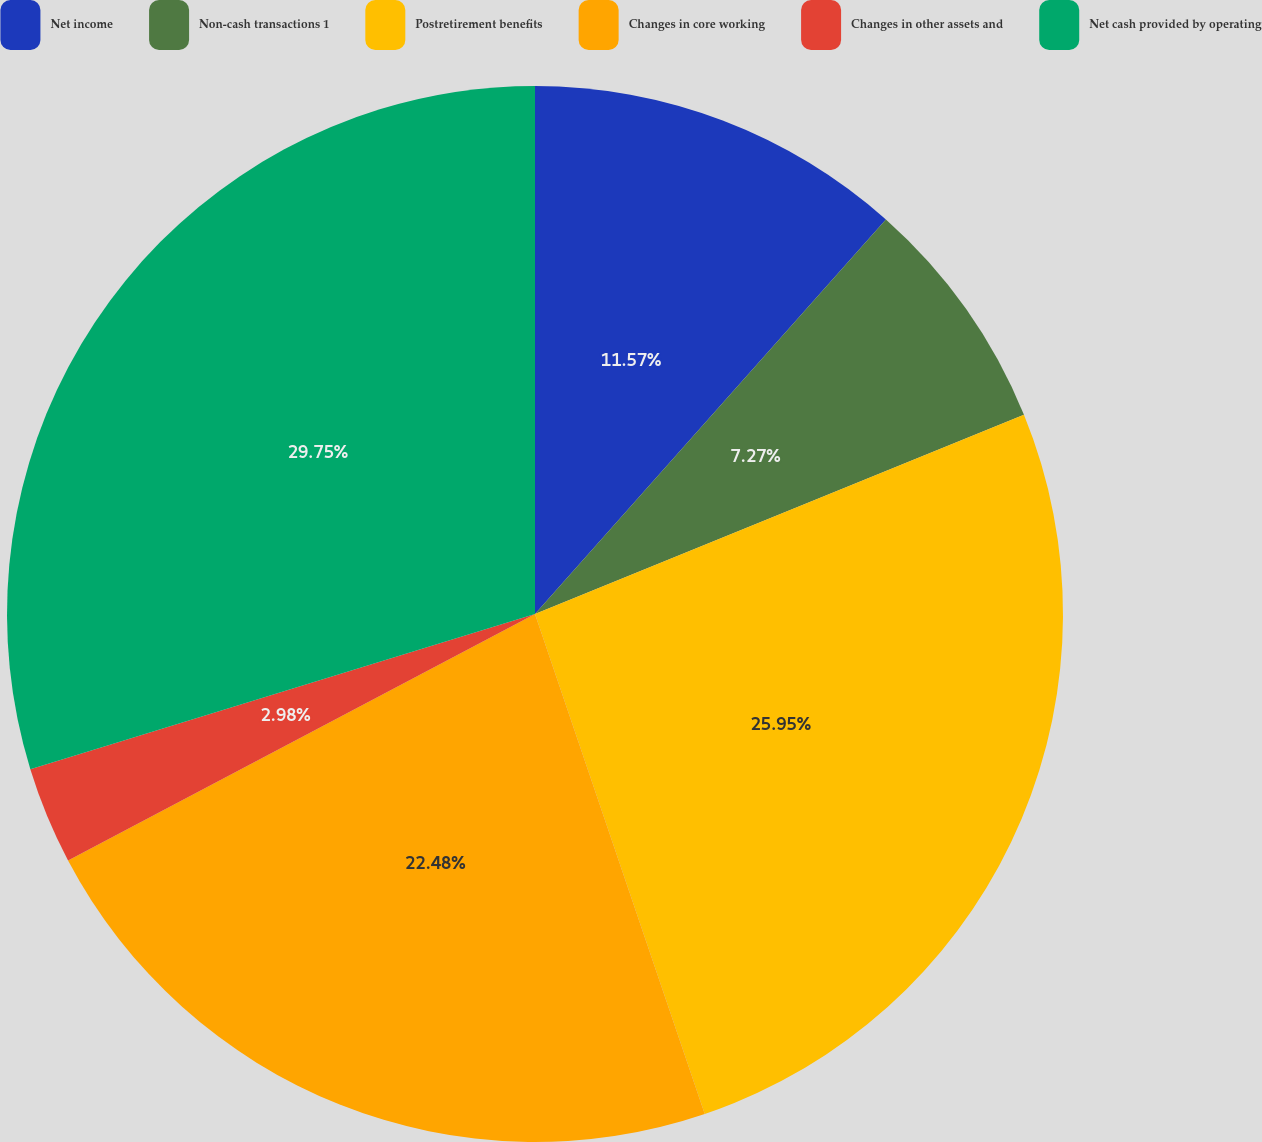Convert chart. <chart><loc_0><loc_0><loc_500><loc_500><pie_chart><fcel>Net income<fcel>Non-cash transactions 1<fcel>Postretirement benefits<fcel>Changes in core working<fcel>Changes in other assets and<fcel>Net cash provided by operating<nl><fcel>11.57%<fcel>7.27%<fcel>25.95%<fcel>22.48%<fcel>2.98%<fcel>29.75%<nl></chart> 